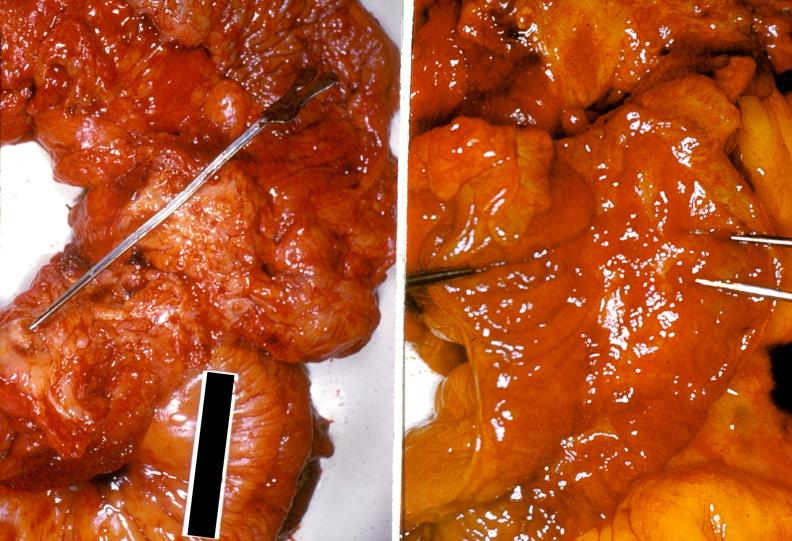where does this belong to?
Answer the question using a single word or phrase. Gastrointestinal system 